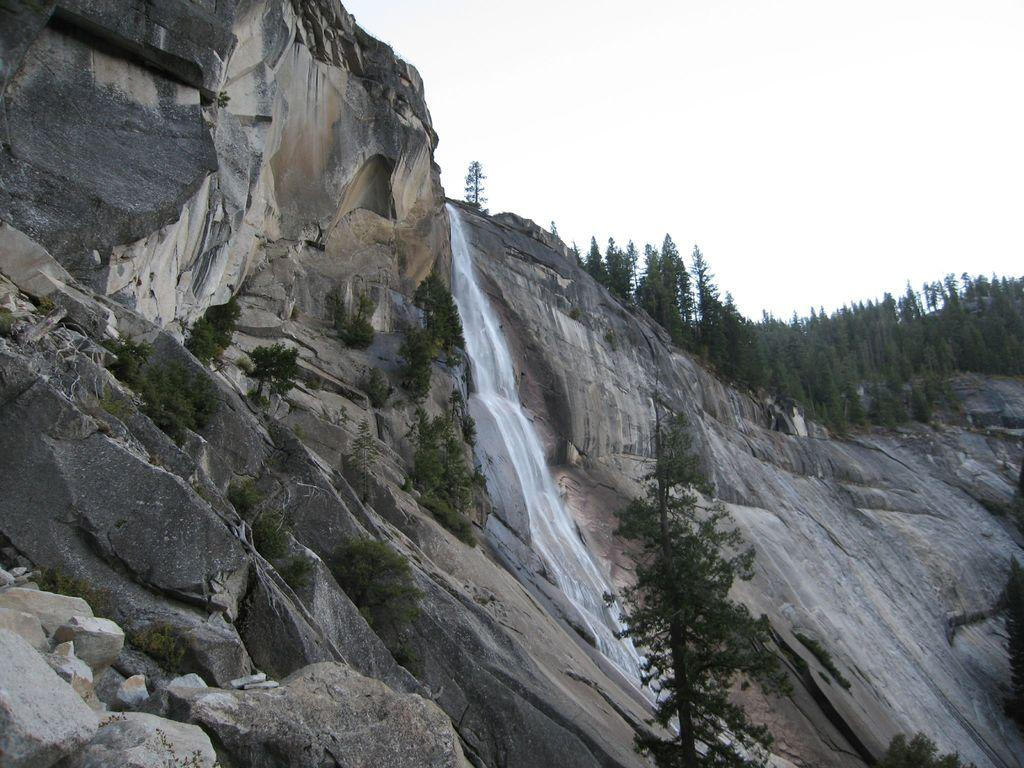What can be seen in the foreground of the image? There are trees, a mountain, and a waterfall in the foreground of the image. What is visible at the top of the image? The sky is visible at the top of the image. Where is the lake located in the image? There is no lake present in the image. How many sheep can be seen grazing near the waterfall in the image? There are no sheep present in the image. 